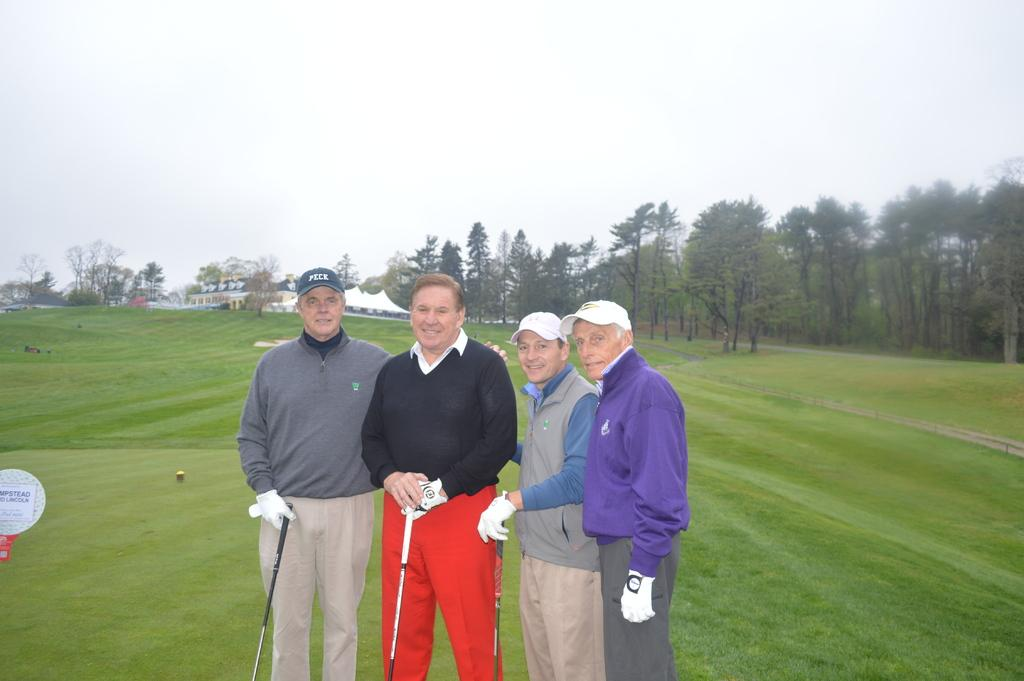How many people are in the image? There are four men in the image. Where are the men located in the image? The men are standing on a golf ground. What can be seen in the background of the image? There are buildings and trees in the background of the image. What is the condition of the sky in the image? The sky is clear in the image. Can you see any ants crawling on the men's shoes in the image? There are no ants visible in the image. What type of building is present in the image? The provided facts do not specify the type of building; only that there are buildings in the background. Is there a hose visible in the image? There is no mention of a hose in the provided facts, so it cannot be determined if one is present in the image. 